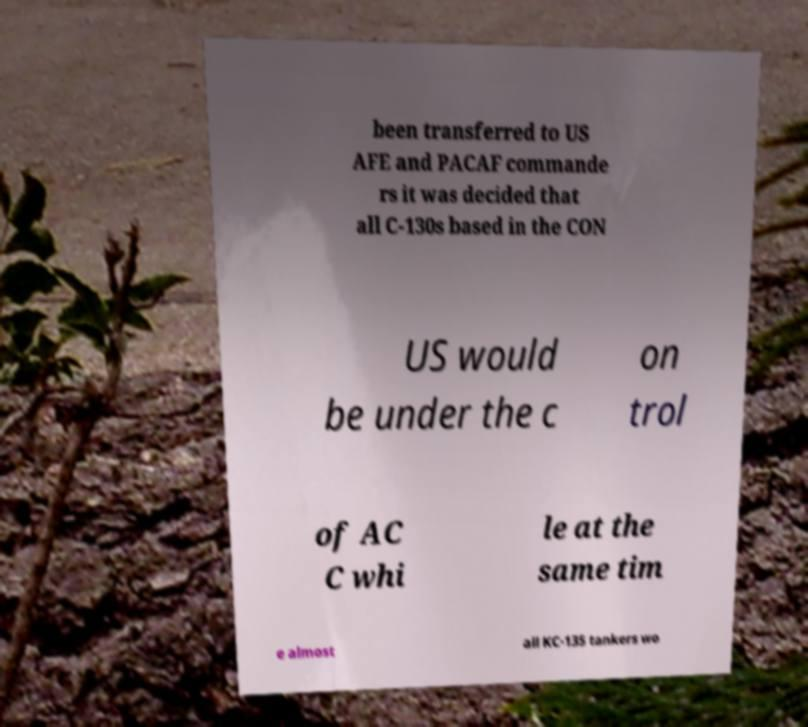Can you accurately transcribe the text from the provided image for me? been transferred to US AFE and PACAF commande rs it was decided that all C-130s based in the CON US would be under the c on trol of AC C whi le at the same tim e almost all KC-135 tankers wo 